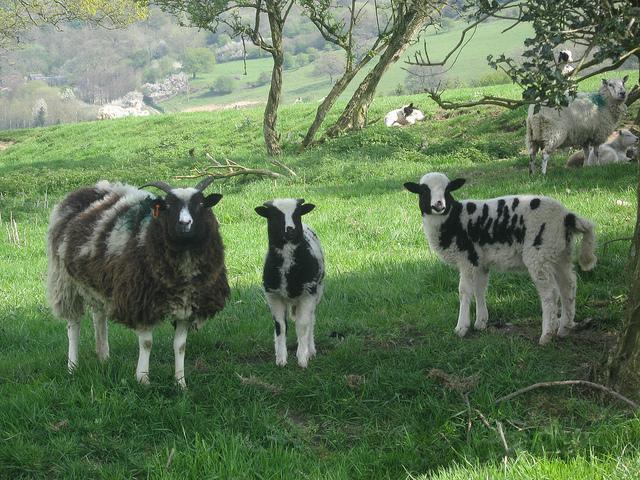How many dogs are in the photo?
Give a very brief answer. 0. How many sheep can you see?
Give a very brief answer. 4. 